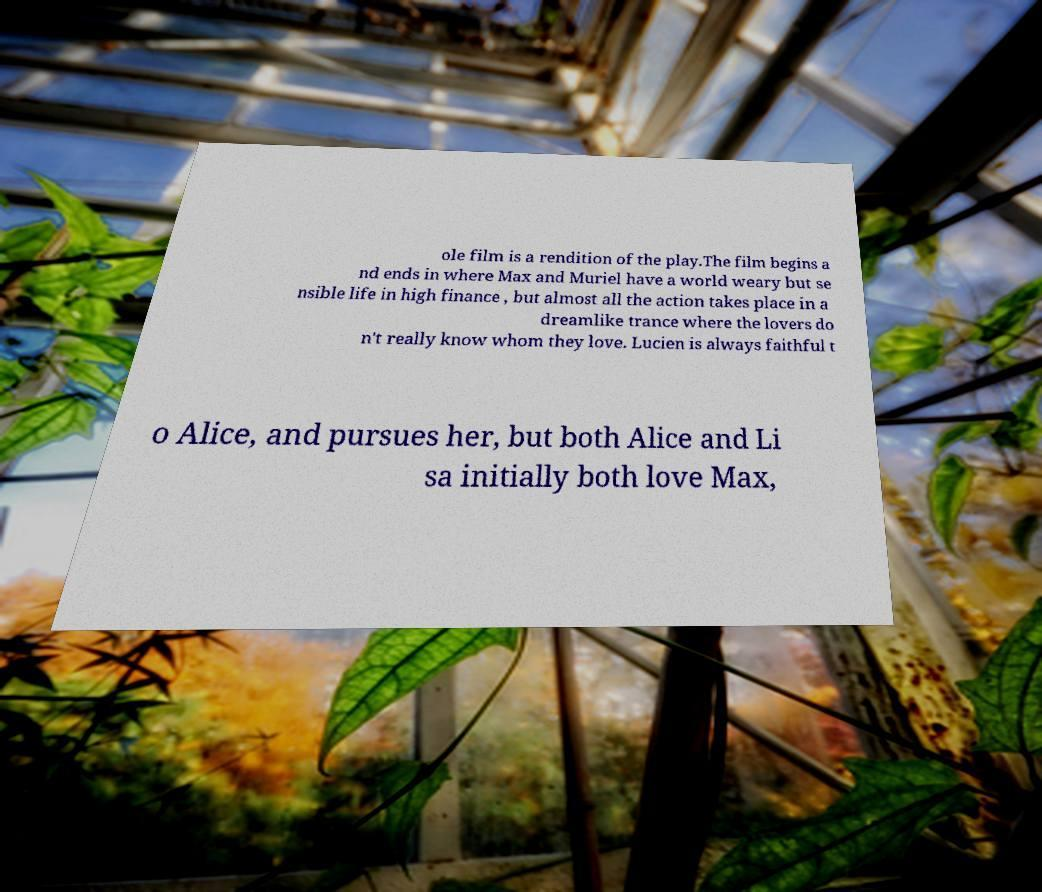There's text embedded in this image that I need extracted. Can you transcribe it verbatim? ole film is a rendition of the play.The film begins a nd ends in where Max and Muriel have a world weary but se nsible life in high finance , but almost all the action takes place in a dreamlike trance where the lovers do n't really know whom they love. Lucien is always faithful t o Alice, and pursues her, but both Alice and Li sa initially both love Max, 